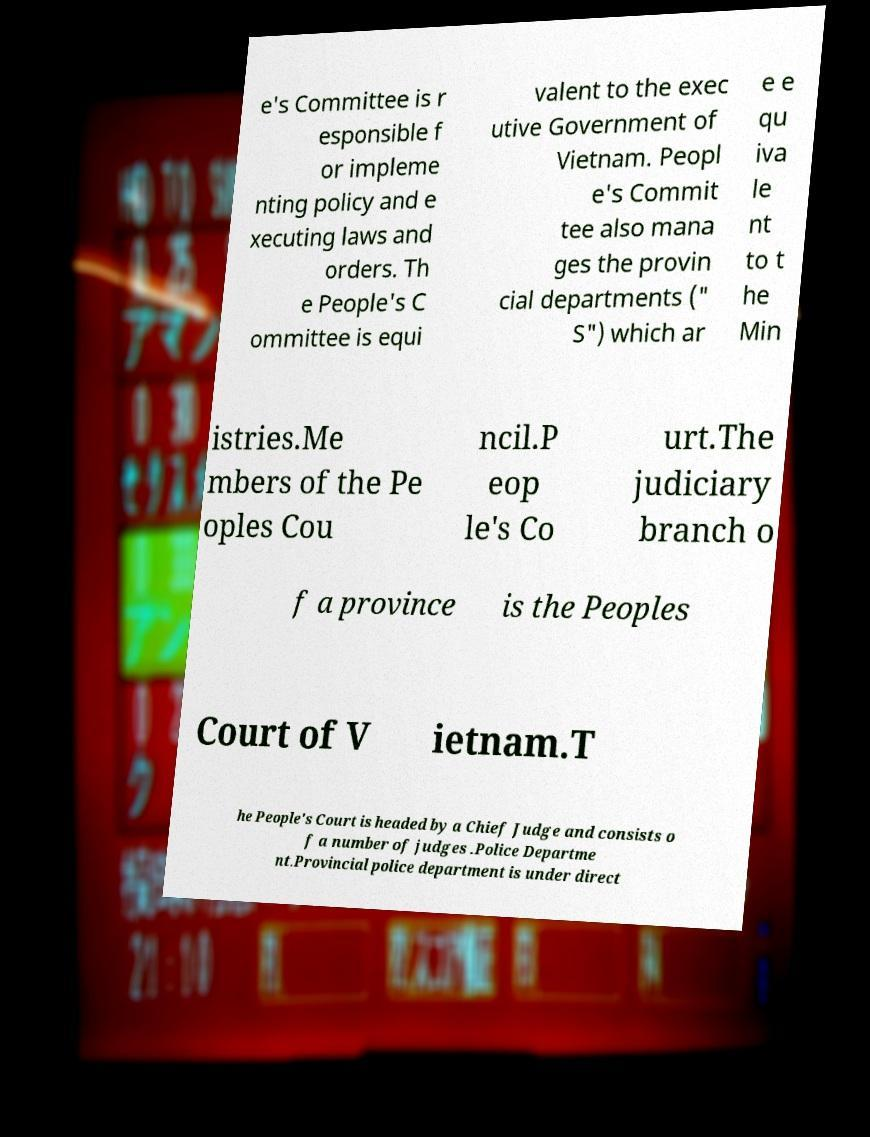Could you assist in decoding the text presented in this image and type it out clearly? e's Committee is r esponsible f or impleme nting policy and e xecuting laws and orders. Th e People's C ommittee is equi valent to the exec utive Government of Vietnam. Peopl e's Commit tee also mana ges the provin cial departments (" S") which ar e e qu iva le nt to t he Min istries.Me mbers of the Pe oples Cou ncil.P eop le's Co urt.The judiciary branch o f a province is the Peoples Court of V ietnam.T he People's Court is headed by a Chief Judge and consists o f a number of judges .Police Departme nt.Provincial police department is under direct 